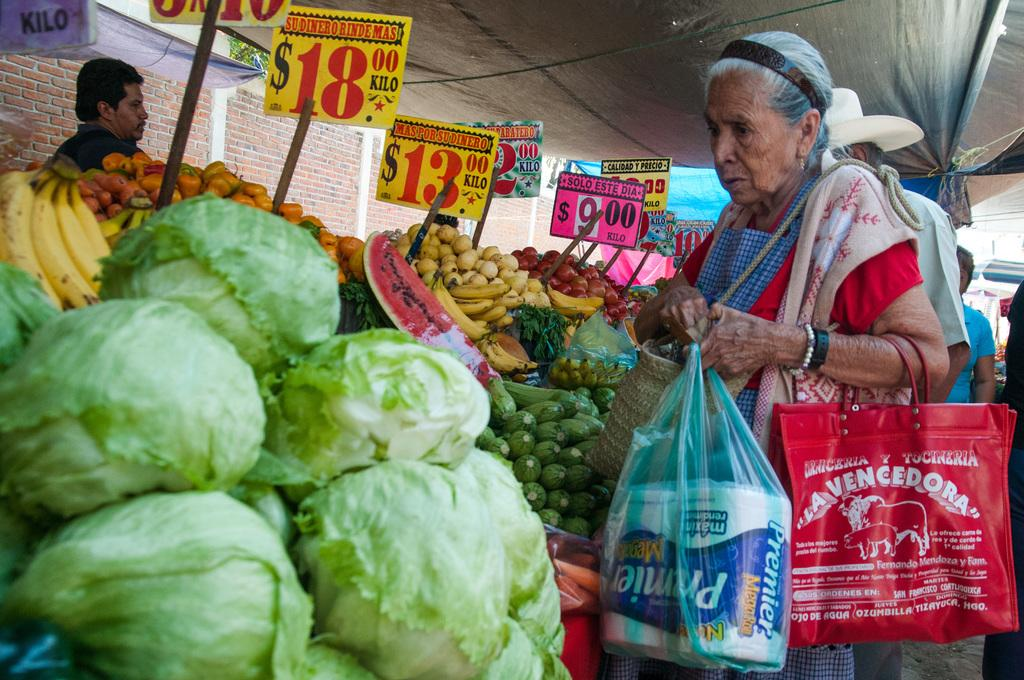What type of location is depicted in the image? The image appears to depict a market. What type of items can be seen in the image? There are vegetables in the image. Who is present in the image? A woman is looking at the vegetables. What might the woman be doing at the market? The woman is carrying bags, which suggests she may be shopping or preparing to shop. Where is the throne located in the image? There is no throne present in the image. Is the woman in the image a spy? There is no indication in the image that the woman is a spy. 